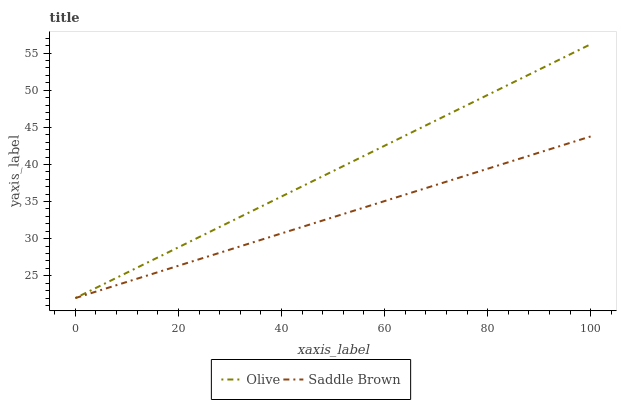Does Saddle Brown have the maximum area under the curve?
Answer yes or no. No. Is Saddle Brown the smoothest?
Answer yes or no. No. Does Saddle Brown have the highest value?
Answer yes or no. No. 